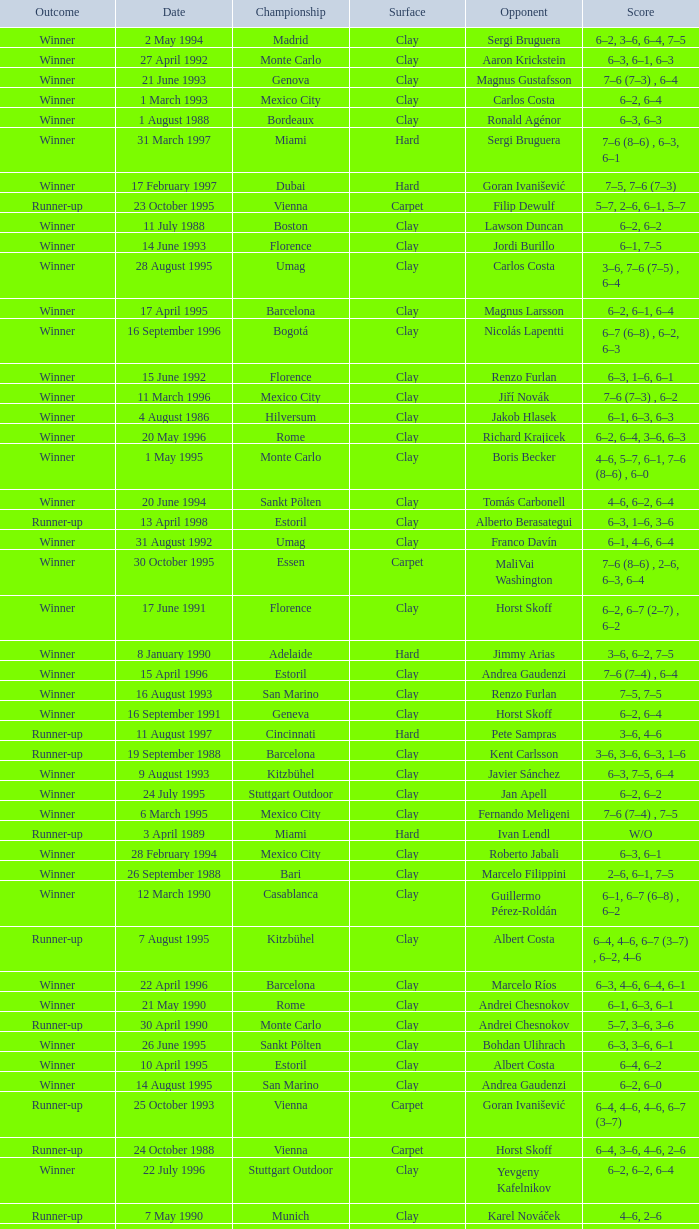Who is the opponent on 18 january 1993? Pete Sampras. 